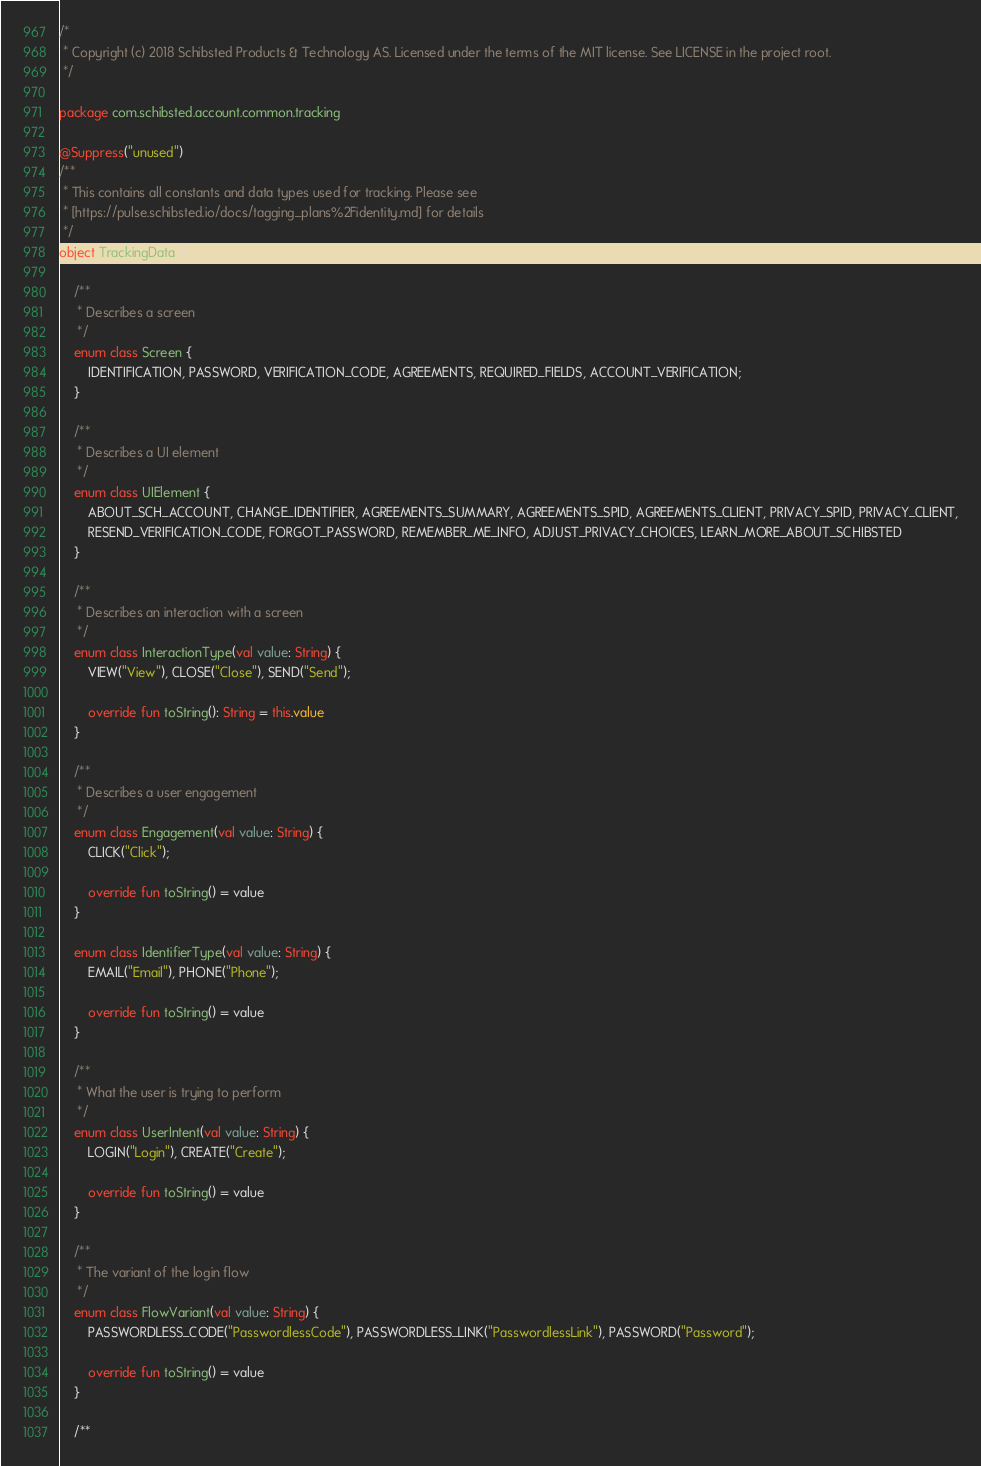<code> <loc_0><loc_0><loc_500><loc_500><_Kotlin_>/*
 * Copyright (c) 2018 Schibsted Products & Technology AS. Licensed under the terms of the MIT license. See LICENSE in the project root.
 */

package com.schibsted.account.common.tracking

@Suppress("unused")
/**
 * This contains all constants and data types used for tracking. Please see
 * [https://pulse.schibsted.io/docs/tagging_plans%2Fidentity.md] for details
 */
object TrackingData {

    /**
     * Describes a screen
     */
    enum class Screen {
        IDENTIFICATION, PASSWORD, VERIFICATION_CODE, AGREEMENTS, REQUIRED_FIELDS, ACCOUNT_VERIFICATION;
    }

    /**
     * Describes a UI element
     */
    enum class UIElement {
        ABOUT_SCH_ACCOUNT, CHANGE_IDENTIFIER, AGREEMENTS_SUMMARY, AGREEMENTS_SPID, AGREEMENTS_CLIENT, PRIVACY_SPID, PRIVACY_CLIENT,
        RESEND_VERIFICATION_CODE, FORGOT_PASSWORD, REMEMBER_ME_INFO, ADJUST_PRIVACY_CHOICES, LEARN_MORE_ABOUT_SCHIBSTED
    }

    /**
     * Describes an interaction with a screen
     */
    enum class InteractionType(val value: String) {
        VIEW("View"), CLOSE("Close"), SEND("Send");

        override fun toString(): String = this.value
    }

    /**
     * Describes a user engagement
     */
    enum class Engagement(val value: String) {
        CLICK("Click");

        override fun toString() = value
    }

    enum class IdentifierType(val value: String) {
        EMAIL("Email"), PHONE("Phone");

        override fun toString() = value
    }

    /**
     * What the user is trying to perform
     */
    enum class UserIntent(val value: String) {
        LOGIN("Login"), CREATE("Create");

        override fun toString() = value
    }

    /**
     * The variant of the login flow
     */
    enum class FlowVariant(val value: String) {
        PASSWORDLESS_CODE("PasswordlessCode"), PASSWORDLESS_LINK("PasswordlessLink"), PASSWORD("Password");

        override fun toString() = value
    }

    /**</code> 